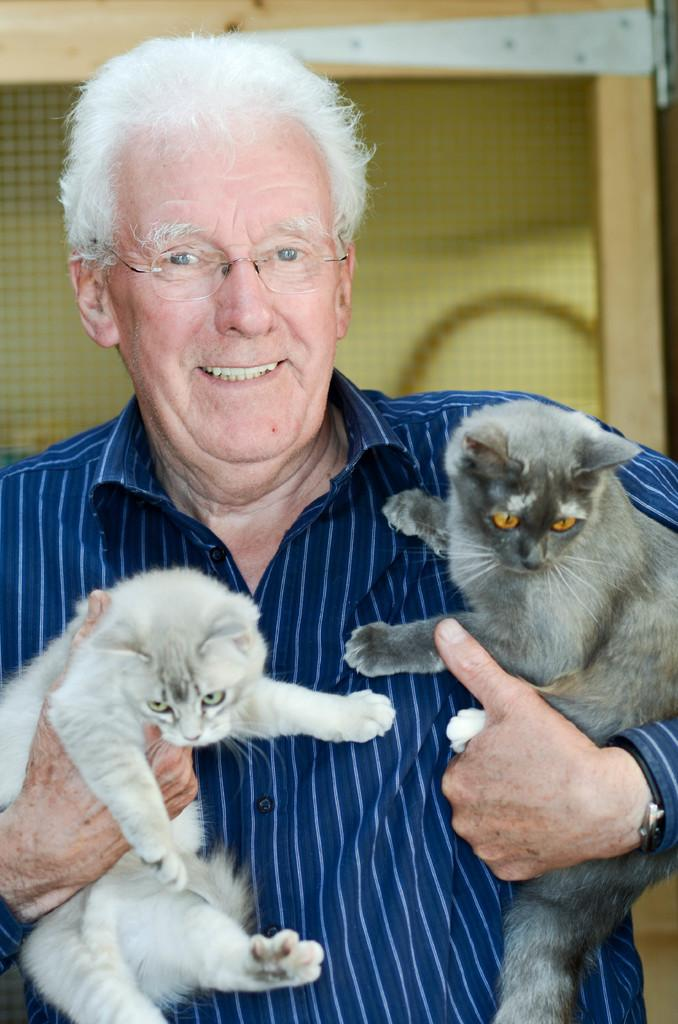Who is the main subject in the image? There is an old man in the image. What is the old man wearing? The old man is wearing a blue shirt. What is the old man holding in his hands? The old man is holding two cats in his hands. What can be seen in the background of the image? There is a net in the background of the image. What type of lift is being used by the old man to hold the cats in the image? There is no lift present in the image; the old man is simply holding the cats in his hands. 